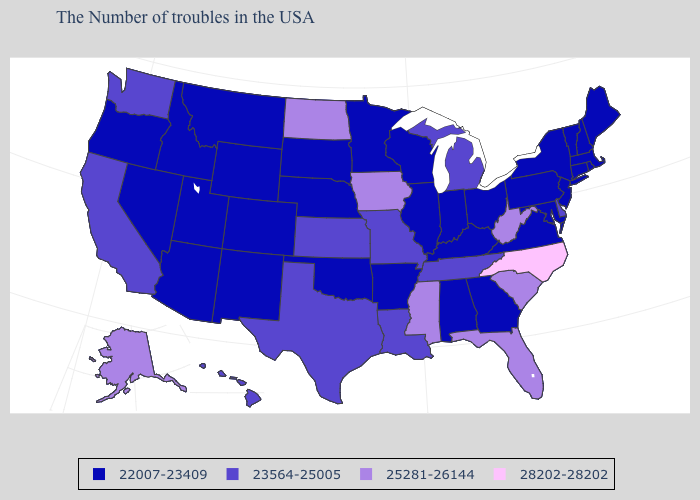Among the states that border Maryland , which have the highest value?
Keep it brief. West Virginia. Does the first symbol in the legend represent the smallest category?
Write a very short answer. Yes. What is the value of Idaho?
Concise answer only. 22007-23409. What is the value of Wisconsin?
Write a very short answer. 22007-23409. Does North Dakota have the highest value in the MidWest?
Be succinct. Yes. What is the highest value in the USA?
Be succinct. 28202-28202. How many symbols are there in the legend?
Keep it brief. 4. Which states hav the highest value in the MidWest?
Answer briefly. Iowa, North Dakota. How many symbols are there in the legend?
Be succinct. 4. Name the states that have a value in the range 25281-26144?
Write a very short answer. South Carolina, West Virginia, Florida, Mississippi, Iowa, North Dakota, Alaska. What is the value of Nebraska?
Answer briefly. 22007-23409. Name the states that have a value in the range 22007-23409?
Short answer required. Maine, Massachusetts, Rhode Island, New Hampshire, Vermont, Connecticut, New York, New Jersey, Maryland, Pennsylvania, Virginia, Ohio, Georgia, Kentucky, Indiana, Alabama, Wisconsin, Illinois, Arkansas, Minnesota, Nebraska, Oklahoma, South Dakota, Wyoming, Colorado, New Mexico, Utah, Montana, Arizona, Idaho, Nevada, Oregon. Does the map have missing data?
Be succinct. No. What is the highest value in the Northeast ?
Keep it brief. 22007-23409. What is the lowest value in the USA?
Write a very short answer. 22007-23409. 